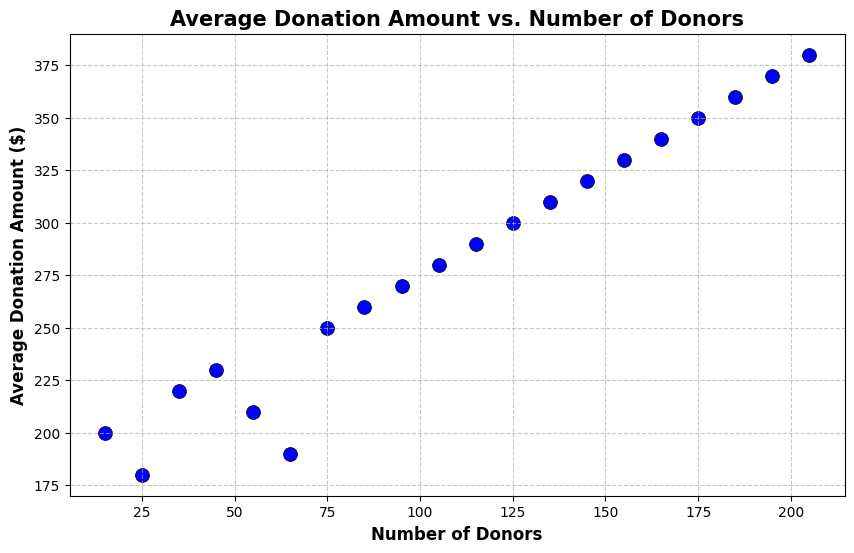What is the range of average donation amounts represented in the figure? The average donation amounts range from the lowest to the highest data points on the y-axis. The lowest point is at $180 and the highest point is at $380.
Answer: $180 to $380 For 75 donors, what is the average donation amount? Locate the point where the x-axis value is 75 and see the corresponding y-axis value. The y-axis value at this point is $250.
Answer: $250 How does the average donation amount change as the number of donors increases from 15 to 45? Compare the y-axis values for x-axis values 15 (average donation $200) and 45 (average donation $230). The average donation amount increases by $230 - $200 = $30.
Answer: Increases by $30 What is the average of the average donation amounts for donor counts of 35, 75, and 155? Identify the average donation amounts for these donor counts: 35 donors ($220), 75 donors ($250), and 155 donors ($330). Sum these amounts: $220 + $250 + $330 = $800. Divide by 3 to find the average: $800 / 3 = $266.67.
Answer: $266.67 Are there any data points where the average donation amount is exactly $300? If so, how many donors are there at that point? Look for the y-axis value of $300 on the chart, then check the x-axis to find the corresponding number of donors. There is one point at $300, which correlates to 125 donors.
Answer: 125 donors How does the average donation amount compare when the number of donors is 65 versus 85? Locate the average donation amounts for 65 donors ($190) and 85 donors ($260). Compare these amounts; $260 is greater than $190.
Answer: 85 donors have a higher amount, $260 versus $190 Does the average donation amount increase consistently as the number of donors increases? Observe the trend line formed by the data points. The trend appears to show a consistent increase in the average donation amount as the number of donors increases.
Answer: Yes, it increases consistently What is the visual trend of the scatter plot as the number of donors increases? The scatter points trend upward, indicating that the average donation amount increases as the number of donors increases.
Answer: Upward trend For 105 donors, is the average donation amount greater than $250? Identify the average donation amount at 105 donors on the y-axis; it is $280, which is greater than $250.
Answer: Yes How much does the average donation amount increase when the number of donors goes from 125 to 145? Identify the average donation amounts at 125 donors ($300) and 145 donors ($320). Subtract to find the increase: $320 - $300 = $20.
Answer: Increases by $20 